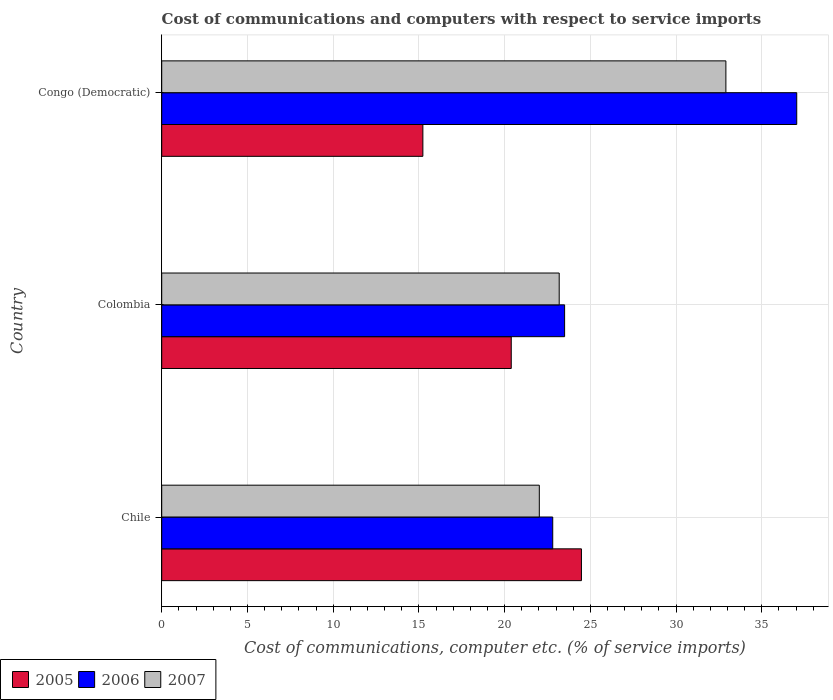How many different coloured bars are there?
Your answer should be compact. 3. How many groups of bars are there?
Provide a short and direct response. 3. What is the label of the 1st group of bars from the top?
Make the answer very short. Congo (Democratic). In how many cases, is the number of bars for a given country not equal to the number of legend labels?
Make the answer very short. 0. What is the cost of communications and computers in 2006 in Chile?
Provide a short and direct response. 22.81. Across all countries, what is the maximum cost of communications and computers in 2005?
Offer a very short reply. 24.48. Across all countries, what is the minimum cost of communications and computers in 2005?
Your answer should be compact. 15.23. What is the total cost of communications and computers in 2006 in the graph?
Your response must be concise. 83.35. What is the difference between the cost of communications and computers in 2007 in Colombia and that in Congo (Democratic)?
Provide a short and direct response. -9.72. What is the difference between the cost of communications and computers in 2007 in Congo (Democratic) and the cost of communications and computers in 2005 in Colombia?
Provide a short and direct response. 12.52. What is the average cost of communications and computers in 2007 per country?
Keep it short and to the point. 26.04. What is the difference between the cost of communications and computers in 2005 and cost of communications and computers in 2006 in Colombia?
Give a very brief answer. -3.11. In how many countries, is the cost of communications and computers in 2005 greater than 13 %?
Keep it short and to the point. 3. What is the ratio of the cost of communications and computers in 2007 in Colombia to that in Congo (Democratic)?
Give a very brief answer. 0.7. Is the cost of communications and computers in 2007 in Chile less than that in Congo (Democratic)?
Your response must be concise. Yes. What is the difference between the highest and the second highest cost of communications and computers in 2006?
Keep it short and to the point. 13.54. What is the difference between the highest and the lowest cost of communications and computers in 2007?
Give a very brief answer. 10.88. In how many countries, is the cost of communications and computers in 2006 greater than the average cost of communications and computers in 2006 taken over all countries?
Your response must be concise. 1. What does the 3rd bar from the bottom in Chile represents?
Ensure brevity in your answer.  2007. How many bars are there?
Your answer should be compact. 9. Are all the bars in the graph horizontal?
Offer a terse response. Yes. How many countries are there in the graph?
Offer a terse response. 3. What is the difference between two consecutive major ticks on the X-axis?
Provide a short and direct response. 5. Does the graph contain any zero values?
Provide a succinct answer. No. Does the graph contain grids?
Ensure brevity in your answer.  Yes. Where does the legend appear in the graph?
Your response must be concise. Bottom left. How many legend labels are there?
Provide a succinct answer. 3. What is the title of the graph?
Your answer should be very brief. Cost of communications and computers with respect to service imports. What is the label or title of the X-axis?
Keep it short and to the point. Cost of communications, computer etc. (% of service imports). What is the Cost of communications, computer etc. (% of service imports) in 2005 in Chile?
Provide a short and direct response. 24.48. What is the Cost of communications, computer etc. (% of service imports) in 2006 in Chile?
Keep it short and to the point. 22.81. What is the Cost of communications, computer etc. (% of service imports) of 2007 in Chile?
Your answer should be very brief. 22.02. What is the Cost of communications, computer etc. (% of service imports) of 2005 in Colombia?
Offer a very short reply. 20.39. What is the Cost of communications, computer etc. (% of service imports) in 2006 in Colombia?
Offer a terse response. 23.5. What is the Cost of communications, computer etc. (% of service imports) of 2007 in Colombia?
Give a very brief answer. 23.18. What is the Cost of communications, computer etc. (% of service imports) of 2005 in Congo (Democratic)?
Your answer should be very brief. 15.23. What is the Cost of communications, computer etc. (% of service imports) in 2006 in Congo (Democratic)?
Offer a very short reply. 37.04. What is the Cost of communications, computer etc. (% of service imports) of 2007 in Congo (Democratic)?
Offer a terse response. 32.91. Across all countries, what is the maximum Cost of communications, computer etc. (% of service imports) in 2005?
Make the answer very short. 24.48. Across all countries, what is the maximum Cost of communications, computer etc. (% of service imports) in 2006?
Your answer should be compact. 37.04. Across all countries, what is the maximum Cost of communications, computer etc. (% of service imports) in 2007?
Your answer should be compact. 32.91. Across all countries, what is the minimum Cost of communications, computer etc. (% of service imports) in 2005?
Make the answer very short. 15.23. Across all countries, what is the minimum Cost of communications, computer etc. (% of service imports) in 2006?
Your answer should be very brief. 22.81. Across all countries, what is the minimum Cost of communications, computer etc. (% of service imports) in 2007?
Keep it short and to the point. 22.02. What is the total Cost of communications, computer etc. (% of service imports) in 2005 in the graph?
Give a very brief answer. 60.1. What is the total Cost of communications, computer etc. (% of service imports) in 2006 in the graph?
Give a very brief answer. 83.35. What is the total Cost of communications, computer etc. (% of service imports) of 2007 in the graph?
Make the answer very short. 78.12. What is the difference between the Cost of communications, computer etc. (% of service imports) of 2005 in Chile and that in Colombia?
Make the answer very short. 4.09. What is the difference between the Cost of communications, computer etc. (% of service imports) in 2006 in Chile and that in Colombia?
Your answer should be compact. -0.69. What is the difference between the Cost of communications, computer etc. (% of service imports) of 2007 in Chile and that in Colombia?
Your response must be concise. -1.16. What is the difference between the Cost of communications, computer etc. (% of service imports) of 2005 in Chile and that in Congo (Democratic)?
Your response must be concise. 9.25. What is the difference between the Cost of communications, computer etc. (% of service imports) in 2006 in Chile and that in Congo (Democratic)?
Provide a succinct answer. -14.23. What is the difference between the Cost of communications, computer etc. (% of service imports) in 2007 in Chile and that in Congo (Democratic)?
Ensure brevity in your answer.  -10.88. What is the difference between the Cost of communications, computer etc. (% of service imports) in 2005 in Colombia and that in Congo (Democratic)?
Your answer should be compact. 5.15. What is the difference between the Cost of communications, computer etc. (% of service imports) of 2006 in Colombia and that in Congo (Democratic)?
Your response must be concise. -13.54. What is the difference between the Cost of communications, computer etc. (% of service imports) of 2007 in Colombia and that in Congo (Democratic)?
Your response must be concise. -9.72. What is the difference between the Cost of communications, computer etc. (% of service imports) in 2005 in Chile and the Cost of communications, computer etc. (% of service imports) in 2006 in Colombia?
Give a very brief answer. 0.98. What is the difference between the Cost of communications, computer etc. (% of service imports) of 2005 in Chile and the Cost of communications, computer etc. (% of service imports) of 2007 in Colombia?
Keep it short and to the point. 1.3. What is the difference between the Cost of communications, computer etc. (% of service imports) in 2006 in Chile and the Cost of communications, computer etc. (% of service imports) in 2007 in Colombia?
Keep it short and to the point. -0.38. What is the difference between the Cost of communications, computer etc. (% of service imports) of 2005 in Chile and the Cost of communications, computer etc. (% of service imports) of 2006 in Congo (Democratic)?
Provide a succinct answer. -12.56. What is the difference between the Cost of communications, computer etc. (% of service imports) in 2005 in Chile and the Cost of communications, computer etc. (% of service imports) in 2007 in Congo (Democratic)?
Your response must be concise. -8.43. What is the difference between the Cost of communications, computer etc. (% of service imports) in 2006 in Chile and the Cost of communications, computer etc. (% of service imports) in 2007 in Congo (Democratic)?
Provide a short and direct response. -10.1. What is the difference between the Cost of communications, computer etc. (% of service imports) in 2005 in Colombia and the Cost of communications, computer etc. (% of service imports) in 2006 in Congo (Democratic)?
Offer a terse response. -16.65. What is the difference between the Cost of communications, computer etc. (% of service imports) in 2005 in Colombia and the Cost of communications, computer etc. (% of service imports) in 2007 in Congo (Democratic)?
Provide a short and direct response. -12.52. What is the difference between the Cost of communications, computer etc. (% of service imports) of 2006 in Colombia and the Cost of communications, computer etc. (% of service imports) of 2007 in Congo (Democratic)?
Your answer should be compact. -9.41. What is the average Cost of communications, computer etc. (% of service imports) in 2005 per country?
Your answer should be compact. 20.03. What is the average Cost of communications, computer etc. (% of service imports) of 2006 per country?
Provide a short and direct response. 27.78. What is the average Cost of communications, computer etc. (% of service imports) in 2007 per country?
Offer a terse response. 26.04. What is the difference between the Cost of communications, computer etc. (% of service imports) in 2005 and Cost of communications, computer etc. (% of service imports) in 2006 in Chile?
Give a very brief answer. 1.67. What is the difference between the Cost of communications, computer etc. (% of service imports) of 2005 and Cost of communications, computer etc. (% of service imports) of 2007 in Chile?
Ensure brevity in your answer.  2.46. What is the difference between the Cost of communications, computer etc. (% of service imports) in 2006 and Cost of communications, computer etc. (% of service imports) in 2007 in Chile?
Your answer should be compact. 0.78. What is the difference between the Cost of communications, computer etc. (% of service imports) of 2005 and Cost of communications, computer etc. (% of service imports) of 2006 in Colombia?
Your answer should be very brief. -3.11. What is the difference between the Cost of communications, computer etc. (% of service imports) in 2005 and Cost of communications, computer etc. (% of service imports) in 2007 in Colombia?
Make the answer very short. -2.8. What is the difference between the Cost of communications, computer etc. (% of service imports) of 2006 and Cost of communications, computer etc. (% of service imports) of 2007 in Colombia?
Offer a terse response. 0.32. What is the difference between the Cost of communications, computer etc. (% of service imports) in 2005 and Cost of communications, computer etc. (% of service imports) in 2006 in Congo (Democratic)?
Keep it short and to the point. -21.81. What is the difference between the Cost of communications, computer etc. (% of service imports) in 2005 and Cost of communications, computer etc. (% of service imports) in 2007 in Congo (Democratic)?
Your answer should be compact. -17.67. What is the difference between the Cost of communications, computer etc. (% of service imports) in 2006 and Cost of communications, computer etc. (% of service imports) in 2007 in Congo (Democratic)?
Your response must be concise. 4.13. What is the ratio of the Cost of communications, computer etc. (% of service imports) in 2005 in Chile to that in Colombia?
Keep it short and to the point. 1.2. What is the ratio of the Cost of communications, computer etc. (% of service imports) of 2006 in Chile to that in Colombia?
Provide a short and direct response. 0.97. What is the ratio of the Cost of communications, computer etc. (% of service imports) of 2005 in Chile to that in Congo (Democratic)?
Provide a short and direct response. 1.61. What is the ratio of the Cost of communications, computer etc. (% of service imports) in 2006 in Chile to that in Congo (Democratic)?
Your answer should be compact. 0.62. What is the ratio of the Cost of communications, computer etc. (% of service imports) of 2007 in Chile to that in Congo (Democratic)?
Your answer should be compact. 0.67. What is the ratio of the Cost of communications, computer etc. (% of service imports) in 2005 in Colombia to that in Congo (Democratic)?
Offer a terse response. 1.34. What is the ratio of the Cost of communications, computer etc. (% of service imports) in 2006 in Colombia to that in Congo (Democratic)?
Provide a short and direct response. 0.63. What is the ratio of the Cost of communications, computer etc. (% of service imports) of 2007 in Colombia to that in Congo (Democratic)?
Give a very brief answer. 0.7. What is the difference between the highest and the second highest Cost of communications, computer etc. (% of service imports) of 2005?
Offer a very short reply. 4.09. What is the difference between the highest and the second highest Cost of communications, computer etc. (% of service imports) of 2006?
Offer a very short reply. 13.54. What is the difference between the highest and the second highest Cost of communications, computer etc. (% of service imports) in 2007?
Keep it short and to the point. 9.72. What is the difference between the highest and the lowest Cost of communications, computer etc. (% of service imports) of 2005?
Your answer should be very brief. 9.25. What is the difference between the highest and the lowest Cost of communications, computer etc. (% of service imports) in 2006?
Ensure brevity in your answer.  14.23. What is the difference between the highest and the lowest Cost of communications, computer etc. (% of service imports) of 2007?
Offer a terse response. 10.88. 